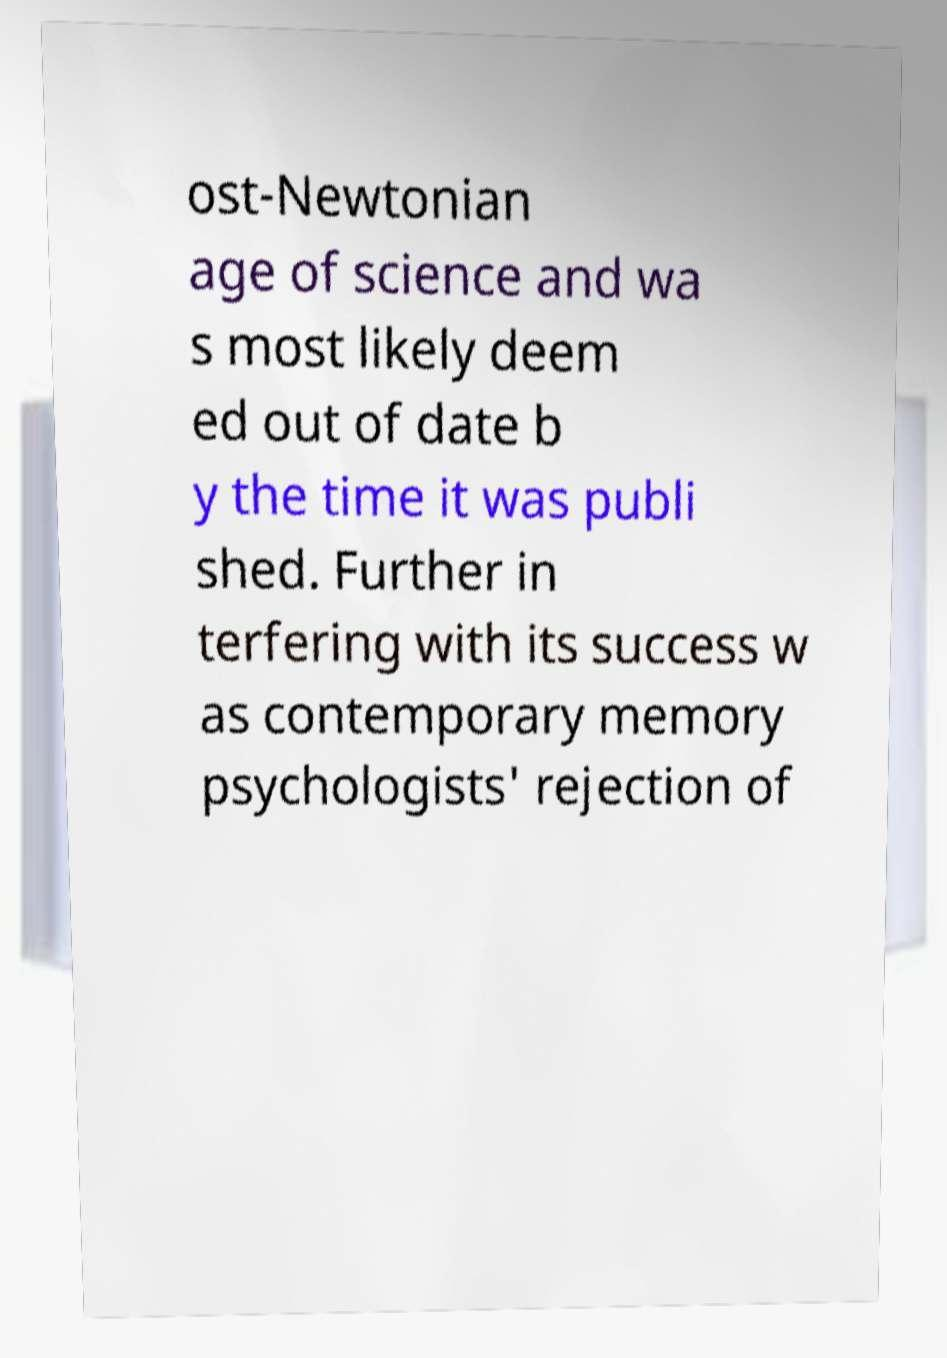There's text embedded in this image that I need extracted. Can you transcribe it verbatim? ost-Newtonian age of science and wa s most likely deem ed out of date b y the time it was publi shed. Further in terfering with its success w as contemporary memory psychologists' rejection of 